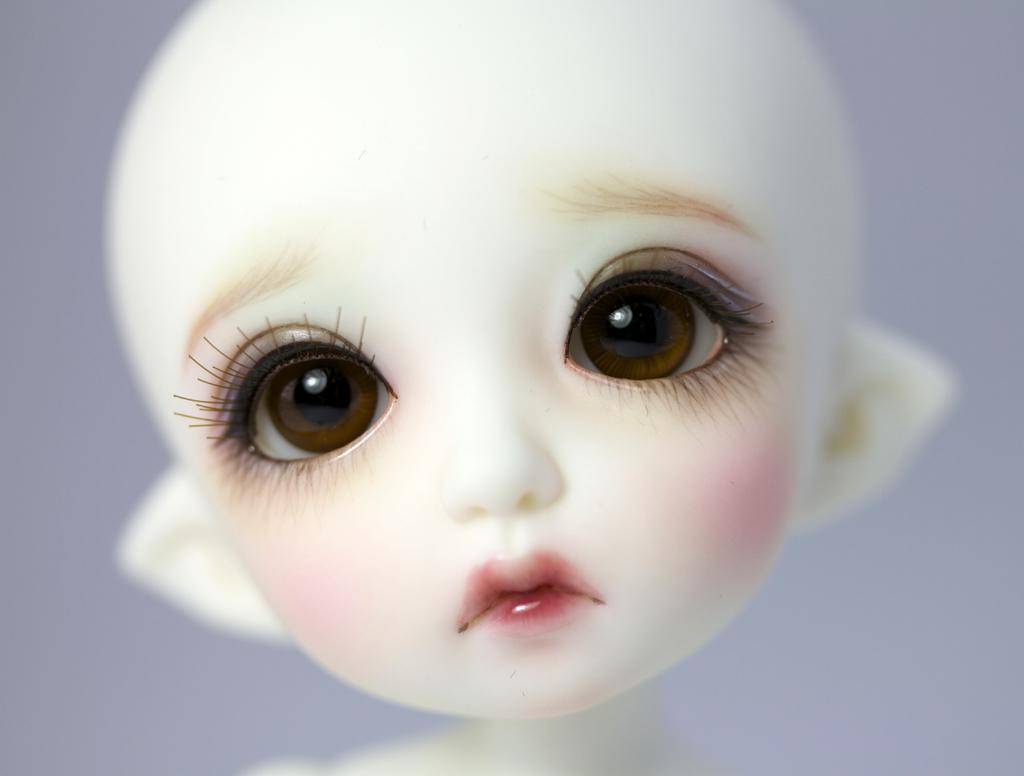What is the main subject of the image? There is a picture of a doll in the image. How many times does the doll say good-bye in the image? The image does not depict the doll speaking or interacting in any way, so it cannot be determined how many times the doll says good-bye. 